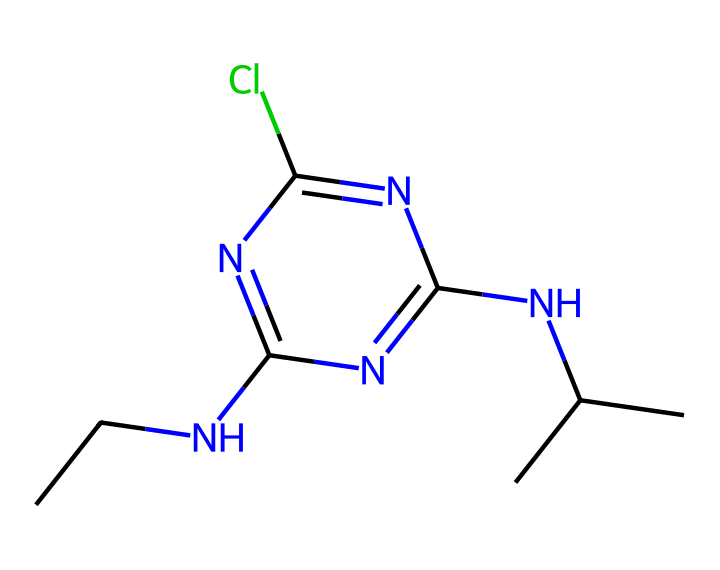What is the primary functional group present in atrazine? The structure contains a carbon-nitrogen bond (C-N), indicating the presence of an amine functional group derived from the alkyl amine structure.
Answer: amine How many chlorine atoms are present in atrazine? By examining the structural representation, there is one chlorine atom connected to the nitrogen-containing aromatic ring, indicating the presence of one chlorine.
Answer: one What is the molecular formula of atrazine? To determine the molecular formula, we can count the number of each type of atom in the structure derived from its SMILES notation: 9 carbons, 14 hydrogens, 5 nitrogens, and 1 chlorine yield the formula C8H10ClN5.
Answer: C8H10ClN5 Does atrazine contain a heterocyclic ring? The presence of a five-membered ring that includes nitrogen atoms indicates that there is a heterocyclic structure: a ring containing atoms other than carbon.
Answer: yes Is atrazine typically classified as a selective or non-selective herbicide? Atrazine is specifically designed to target certain types of weeds while minimizing harm to desired crops, therefore classifying it as a selective herbicide.
Answer: selective How many nitrogen atoms are there in atrazine? By analyzing the chemical structure, we can see there are four nitrogen atoms present, contributing to the overall composition of the herbicide.
Answer: four What is the significance of the alkyl group in atrazine's structure? The alkyl group (specifically, the isopropyl group seen in the structure) contributes to the herbicide's lipophilicity, influencing its effectiveness and absorption in plants.
Answer: lipophilicity 